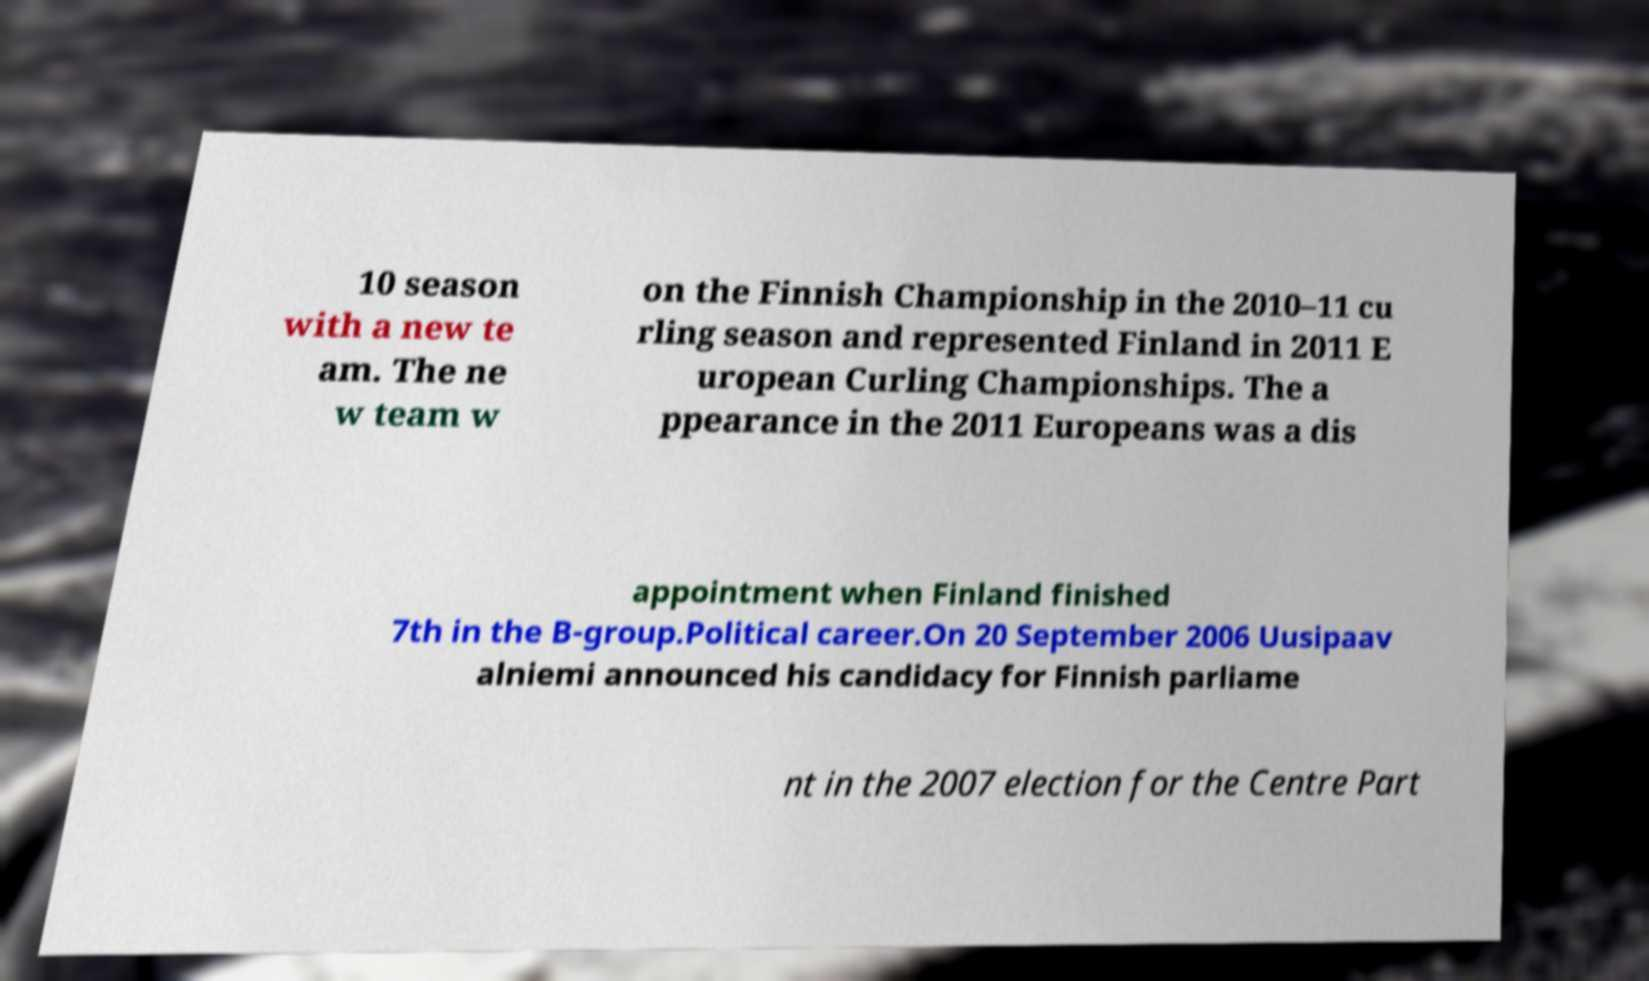There's text embedded in this image that I need extracted. Can you transcribe it verbatim? 10 season with a new te am. The ne w team w on the Finnish Championship in the 2010–11 cu rling season and represented Finland in 2011 E uropean Curling Championships. The a ppearance in the 2011 Europeans was a dis appointment when Finland finished 7th in the B-group.Political career.On 20 September 2006 Uusipaav alniemi announced his candidacy for Finnish parliame nt in the 2007 election for the Centre Part 